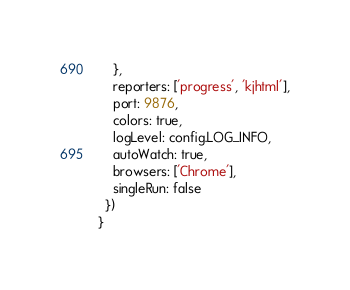<code> <loc_0><loc_0><loc_500><loc_500><_JavaScript_>    },
    reporters: ['progress', 'kjhtml'],
    port: 9876,
    colors: true,
    logLevel: config.LOG_INFO,
    autoWatch: true,
    browsers: ['Chrome'],
    singleRun: false
  })
}
</code> 